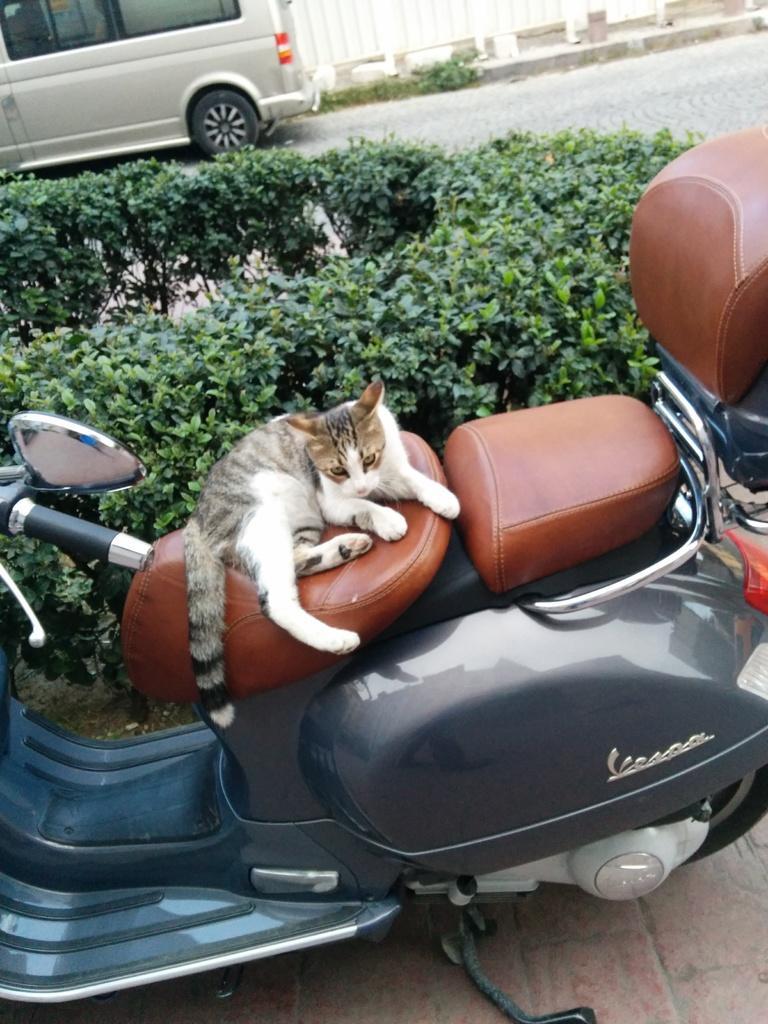How would you summarize this image in a sentence or two? In this picture we can see a cat sitting on scooter and in background we can see a vehicle on road, trees. 